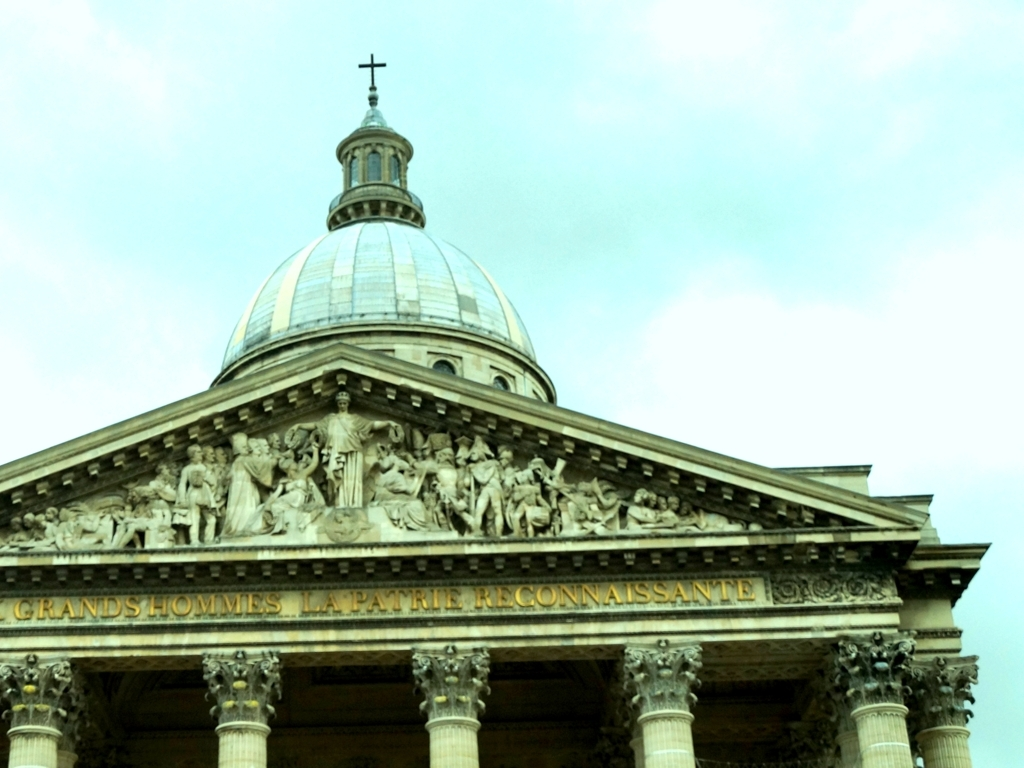Is the color tone of the image relatively monotone? Yes, the image predominantly displays a variety of greenish hues creating a monotone effect; however, there are subtle variations, including the lighter tones on the dome and the darker greens in the shadowy areas, which add some depth to the visual experience. 